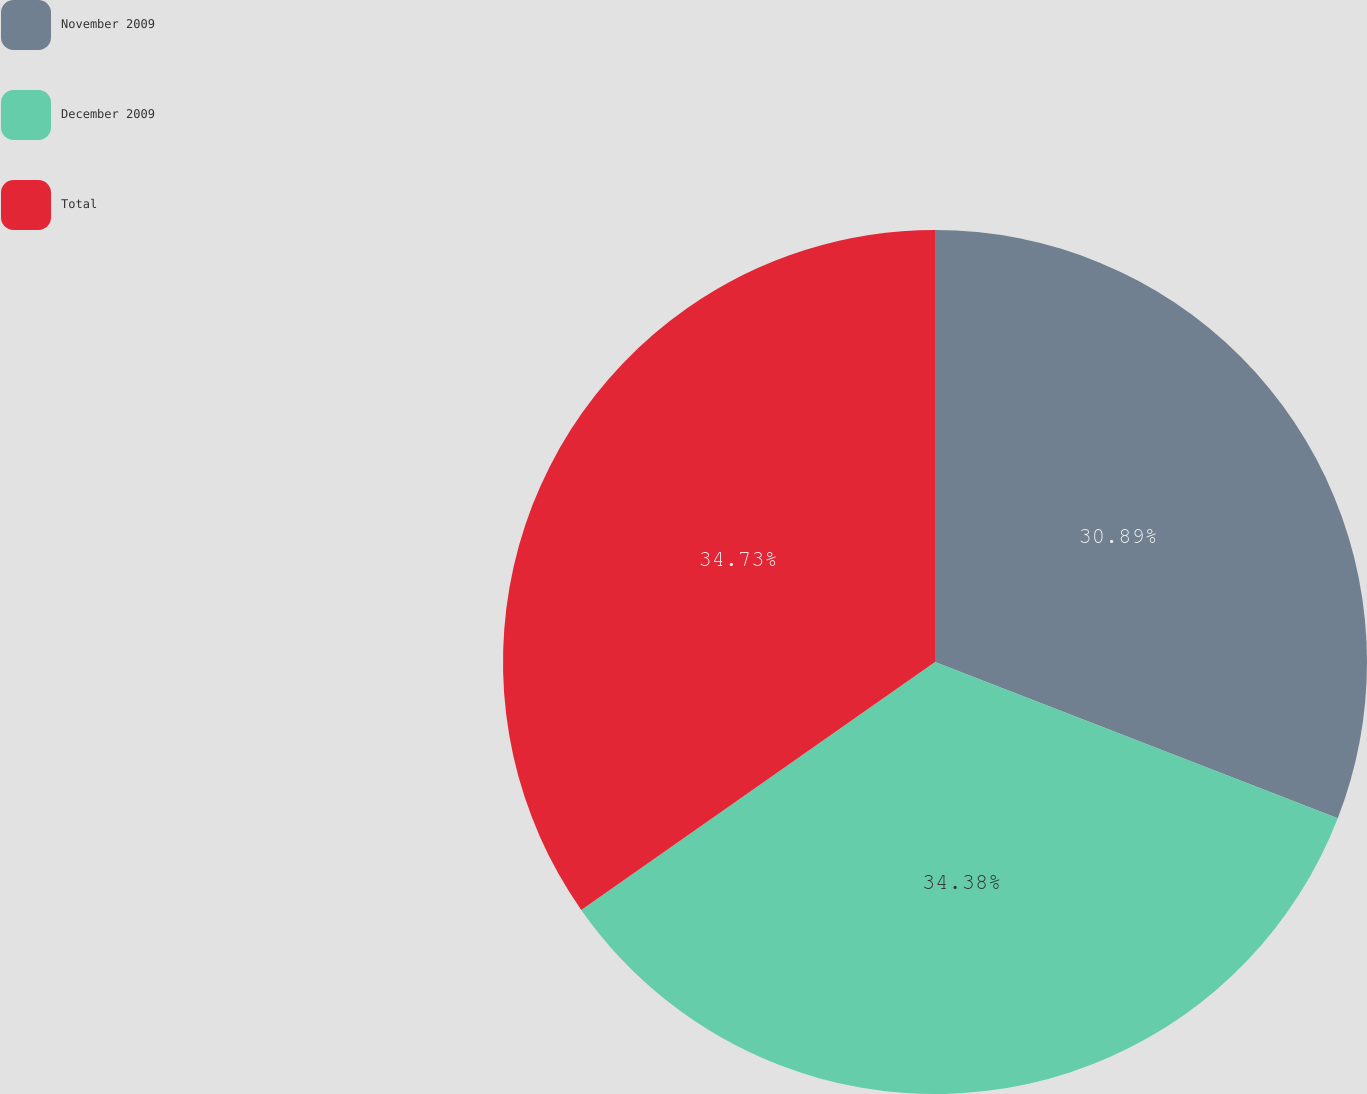<chart> <loc_0><loc_0><loc_500><loc_500><pie_chart><fcel>November 2009<fcel>December 2009<fcel>Total<nl><fcel>30.89%<fcel>34.38%<fcel>34.73%<nl></chart> 